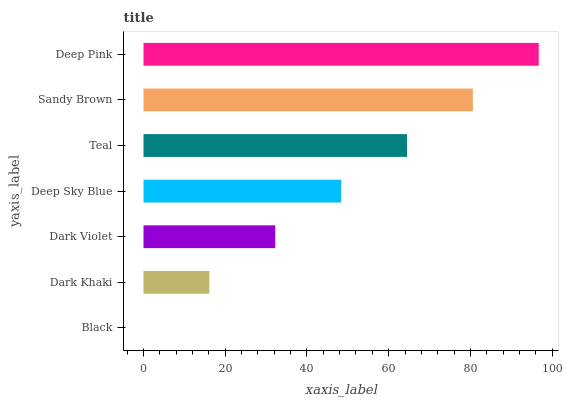Is Black the minimum?
Answer yes or no. Yes. Is Deep Pink the maximum?
Answer yes or no. Yes. Is Dark Khaki the minimum?
Answer yes or no. No. Is Dark Khaki the maximum?
Answer yes or no. No. Is Dark Khaki greater than Black?
Answer yes or no. Yes. Is Black less than Dark Khaki?
Answer yes or no. Yes. Is Black greater than Dark Khaki?
Answer yes or no. No. Is Dark Khaki less than Black?
Answer yes or no. No. Is Deep Sky Blue the high median?
Answer yes or no. Yes. Is Deep Sky Blue the low median?
Answer yes or no. Yes. Is Teal the high median?
Answer yes or no. No. Is Dark Khaki the low median?
Answer yes or no. No. 